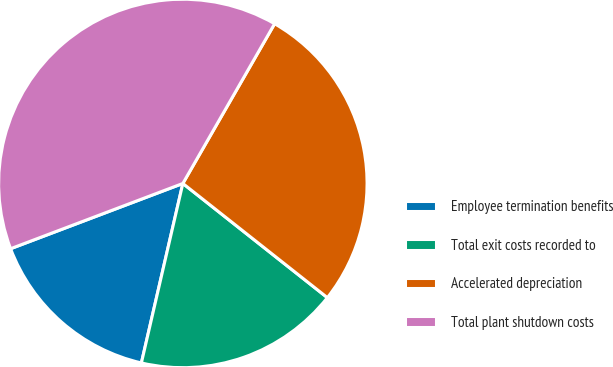<chart> <loc_0><loc_0><loc_500><loc_500><pie_chart><fcel>Employee termination benefits<fcel>Total exit costs recorded to<fcel>Accelerated depreciation<fcel>Total plant shutdown costs<nl><fcel>15.62%<fcel>17.97%<fcel>27.34%<fcel>39.06%<nl></chart> 